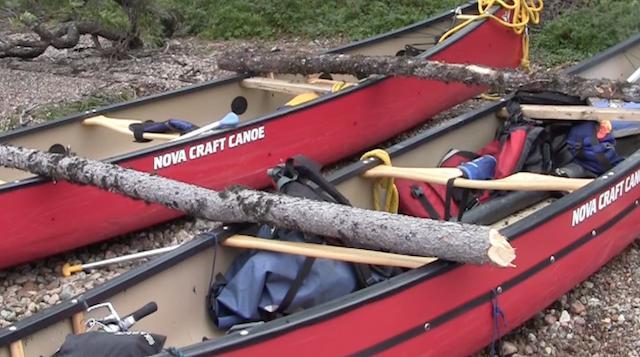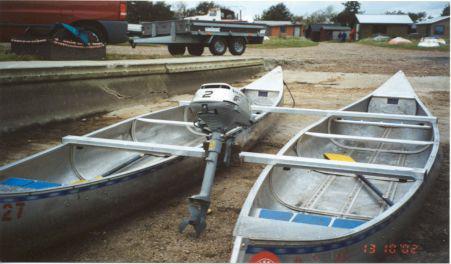The first image is the image on the left, the second image is the image on the right. Analyze the images presented: Is the assertion "There are at least half a dozen people in the boats." valid? Answer yes or no. No. The first image is the image on the left, the second image is the image on the right. Examine the images to the left and right. Is the description "In each image, one or more persons is shown with a double canoe that is built with a solid flat platform between the two canoes." accurate? Answer yes or no. No. 